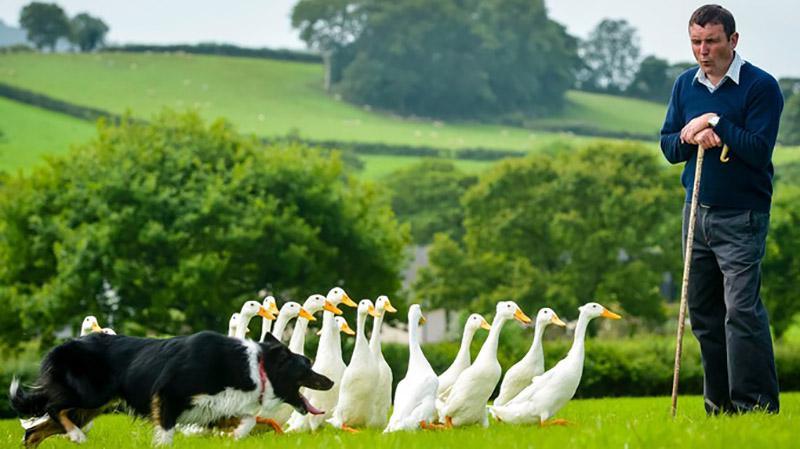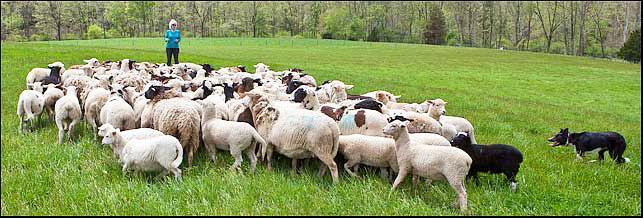The first image is the image on the left, the second image is the image on the right. Evaluate the accuracy of this statement regarding the images: "One image shows a dog herding water fowl.". Is it true? Answer yes or no. Yes. The first image is the image on the left, the second image is the image on the right. Examine the images to the left and right. Is the description "The sheep are near an enclosure." accurate? Answer yes or no. No. 